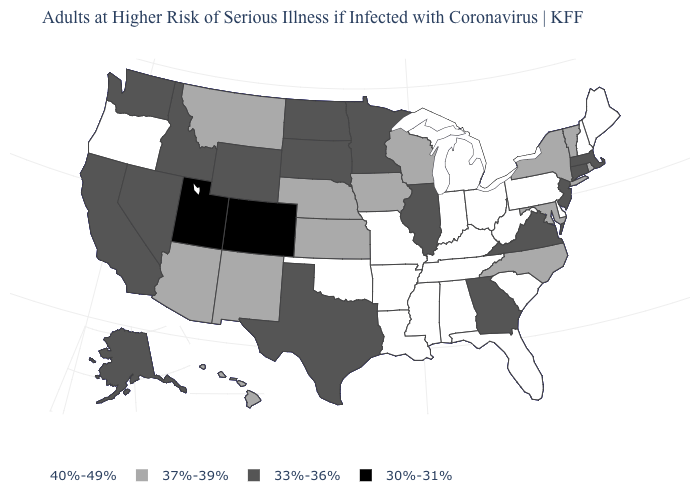Name the states that have a value in the range 33%-36%?
Concise answer only. Alaska, California, Connecticut, Georgia, Idaho, Illinois, Massachusetts, Minnesota, Nevada, New Jersey, North Dakota, South Dakota, Texas, Virginia, Washington, Wyoming. What is the value of New Mexico?
Keep it brief. 37%-39%. Name the states that have a value in the range 30%-31%?
Write a very short answer. Colorado, Utah. What is the value of Nevada?
Give a very brief answer. 33%-36%. What is the value of Vermont?
Keep it brief. 37%-39%. How many symbols are there in the legend?
Write a very short answer. 4. Which states have the lowest value in the USA?
Give a very brief answer. Colorado, Utah. Name the states that have a value in the range 30%-31%?
Be succinct. Colorado, Utah. What is the lowest value in states that border Missouri?
Give a very brief answer. 33%-36%. Name the states that have a value in the range 40%-49%?
Write a very short answer. Alabama, Arkansas, Delaware, Florida, Indiana, Kentucky, Louisiana, Maine, Michigan, Mississippi, Missouri, New Hampshire, Ohio, Oklahoma, Oregon, Pennsylvania, South Carolina, Tennessee, West Virginia. Does Iowa have the highest value in the MidWest?
Concise answer only. No. Name the states that have a value in the range 37%-39%?
Quick response, please. Arizona, Hawaii, Iowa, Kansas, Maryland, Montana, Nebraska, New Mexico, New York, North Carolina, Rhode Island, Vermont, Wisconsin. Name the states that have a value in the range 37%-39%?
Write a very short answer. Arizona, Hawaii, Iowa, Kansas, Maryland, Montana, Nebraska, New Mexico, New York, North Carolina, Rhode Island, Vermont, Wisconsin. Does Texas have the same value as Kentucky?
Concise answer only. No. Name the states that have a value in the range 30%-31%?
Quick response, please. Colorado, Utah. 